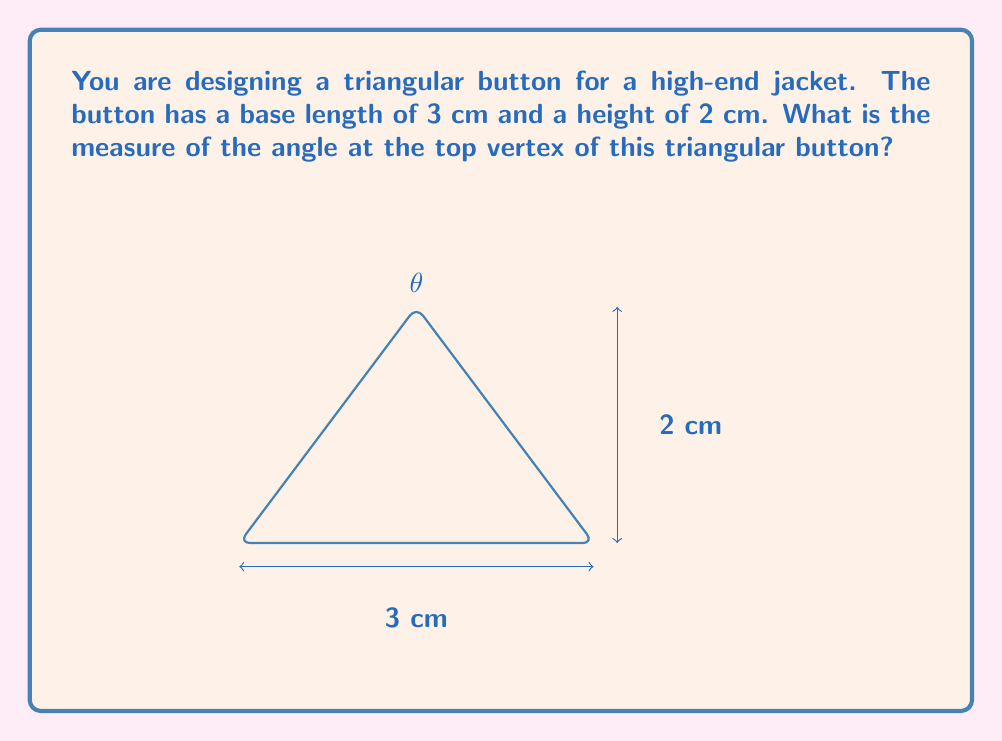What is the answer to this math problem? Let's approach this step-by-step:

1) The triangle formed by the button is an isosceles triangle, as the top vertex is centered above the base.

2) We can split this isosceles triangle into two right triangles by drawing a perpendicular line from the top vertex to the base.

3) Let's focus on one of these right triangles. We know:
   - The base of this right triangle is half of the original base: $\frac{3}{2} = 1.5$ cm
   - The height remains 2 cm

4) In this right triangle, we can use the arctangent function to find the angle $\theta$:

   $$\tan(\theta) = \frac{\text{opposite}}{\text{adjacent}} = \frac{2}{1.5}$$

5) Therefore:

   $$\theta = \arctan(\frac{2}{1.5})$$

6) Using a calculator or trigonometric tables:

   $$\theta \approx 53.13^\circ$$

7) This is the angle for half of the isosceles triangle. The full angle at the top vertex is twice this:

   $$\text{Full angle} = 2\theta \approx 2 * 53.13^\circ = 106.26^\circ$$
Answer: The measure of the angle at the top vertex of the triangular button is approximately $106.26^\circ$. 